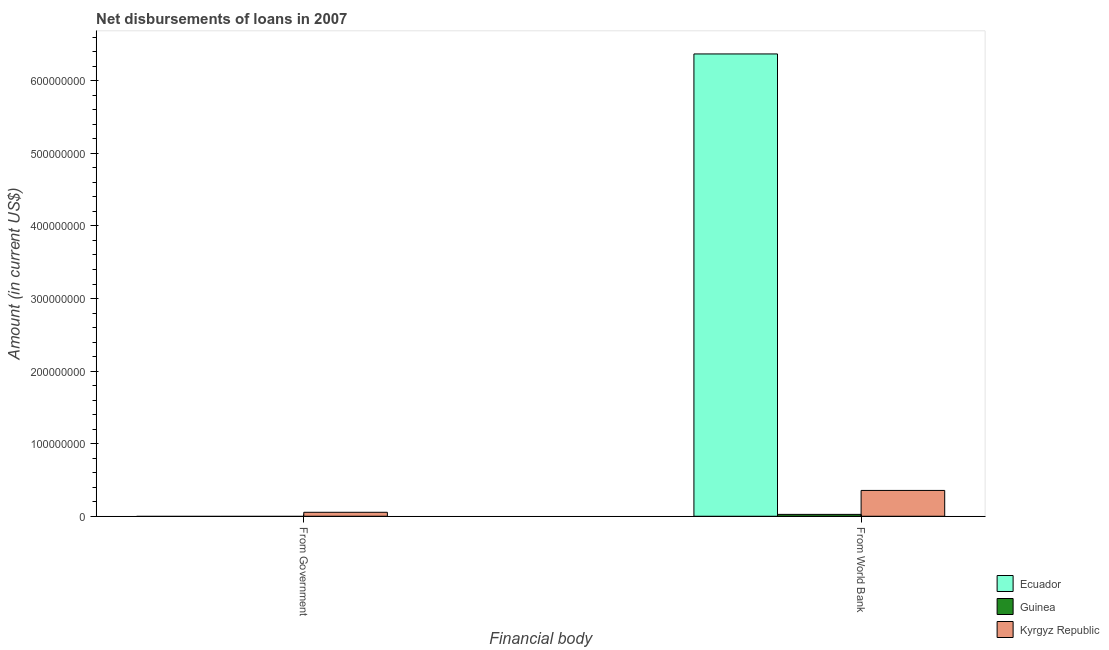Are the number of bars per tick equal to the number of legend labels?
Provide a short and direct response. No. Are the number of bars on each tick of the X-axis equal?
Keep it short and to the point. No. How many bars are there on the 1st tick from the right?
Make the answer very short. 3. What is the label of the 2nd group of bars from the left?
Offer a very short reply. From World Bank. What is the net disbursements of loan from world bank in Ecuador?
Your response must be concise. 6.37e+08. Across all countries, what is the maximum net disbursements of loan from world bank?
Keep it short and to the point. 6.37e+08. Across all countries, what is the minimum net disbursements of loan from world bank?
Your response must be concise. 2.57e+06. In which country was the net disbursements of loan from world bank maximum?
Your response must be concise. Ecuador. What is the total net disbursements of loan from government in the graph?
Offer a very short reply. 5.46e+06. What is the difference between the net disbursements of loan from world bank in Ecuador and that in Kyrgyz Republic?
Give a very brief answer. 6.01e+08. What is the difference between the net disbursements of loan from world bank in Guinea and the net disbursements of loan from government in Kyrgyz Republic?
Provide a short and direct response. -2.89e+06. What is the average net disbursements of loan from government per country?
Provide a succinct answer. 1.82e+06. What is the difference between the net disbursements of loan from world bank and net disbursements of loan from government in Kyrgyz Republic?
Offer a very short reply. 3.01e+07. What is the ratio of the net disbursements of loan from world bank in Ecuador to that in Kyrgyz Republic?
Your answer should be compact. 17.9. In how many countries, is the net disbursements of loan from world bank greater than the average net disbursements of loan from world bank taken over all countries?
Your answer should be very brief. 1. Are all the bars in the graph horizontal?
Keep it short and to the point. No. Are the values on the major ticks of Y-axis written in scientific E-notation?
Your answer should be very brief. No. Does the graph contain grids?
Ensure brevity in your answer.  No. How many legend labels are there?
Give a very brief answer. 3. What is the title of the graph?
Your answer should be compact. Net disbursements of loans in 2007. Does "Colombia" appear as one of the legend labels in the graph?
Your answer should be very brief. No. What is the label or title of the X-axis?
Offer a terse response. Financial body. What is the label or title of the Y-axis?
Provide a succinct answer. Amount (in current US$). What is the Amount (in current US$) of Guinea in From Government?
Keep it short and to the point. 0. What is the Amount (in current US$) of Kyrgyz Republic in From Government?
Give a very brief answer. 5.46e+06. What is the Amount (in current US$) of Ecuador in From World Bank?
Give a very brief answer. 6.37e+08. What is the Amount (in current US$) of Guinea in From World Bank?
Offer a very short reply. 2.57e+06. What is the Amount (in current US$) of Kyrgyz Republic in From World Bank?
Your response must be concise. 3.56e+07. Across all Financial body, what is the maximum Amount (in current US$) of Ecuador?
Your response must be concise. 6.37e+08. Across all Financial body, what is the maximum Amount (in current US$) in Guinea?
Keep it short and to the point. 2.57e+06. Across all Financial body, what is the maximum Amount (in current US$) in Kyrgyz Republic?
Offer a terse response. 3.56e+07. Across all Financial body, what is the minimum Amount (in current US$) of Guinea?
Give a very brief answer. 0. Across all Financial body, what is the minimum Amount (in current US$) in Kyrgyz Republic?
Offer a very short reply. 5.46e+06. What is the total Amount (in current US$) in Ecuador in the graph?
Provide a succinct answer. 6.37e+08. What is the total Amount (in current US$) of Guinea in the graph?
Make the answer very short. 2.57e+06. What is the total Amount (in current US$) in Kyrgyz Republic in the graph?
Your response must be concise. 4.11e+07. What is the difference between the Amount (in current US$) of Kyrgyz Republic in From Government and that in From World Bank?
Provide a short and direct response. -3.01e+07. What is the average Amount (in current US$) in Ecuador per Financial body?
Offer a terse response. 3.19e+08. What is the average Amount (in current US$) in Guinea per Financial body?
Your answer should be compact. 1.29e+06. What is the average Amount (in current US$) in Kyrgyz Republic per Financial body?
Keep it short and to the point. 2.05e+07. What is the difference between the Amount (in current US$) of Ecuador and Amount (in current US$) of Guinea in From World Bank?
Your response must be concise. 6.34e+08. What is the difference between the Amount (in current US$) in Ecuador and Amount (in current US$) in Kyrgyz Republic in From World Bank?
Your answer should be compact. 6.01e+08. What is the difference between the Amount (in current US$) of Guinea and Amount (in current US$) of Kyrgyz Republic in From World Bank?
Your answer should be very brief. -3.30e+07. What is the ratio of the Amount (in current US$) in Kyrgyz Republic in From Government to that in From World Bank?
Make the answer very short. 0.15. What is the difference between the highest and the second highest Amount (in current US$) in Kyrgyz Republic?
Your response must be concise. 3.01e+07. What is the difference between the highest and the lowest Amount (in current US$) in Ecuador?
Your answer should be compact. 6.37e+08. What is the difference between the highest and the lowest Amount (in current US$) in Guinea?
Provide a succinct answer. 2.57e+06. What is the difference between the highest and the lowest Amount (in current US$) of Kyrgyz Republic?
Offer a very short reply. 3.01e+07. 